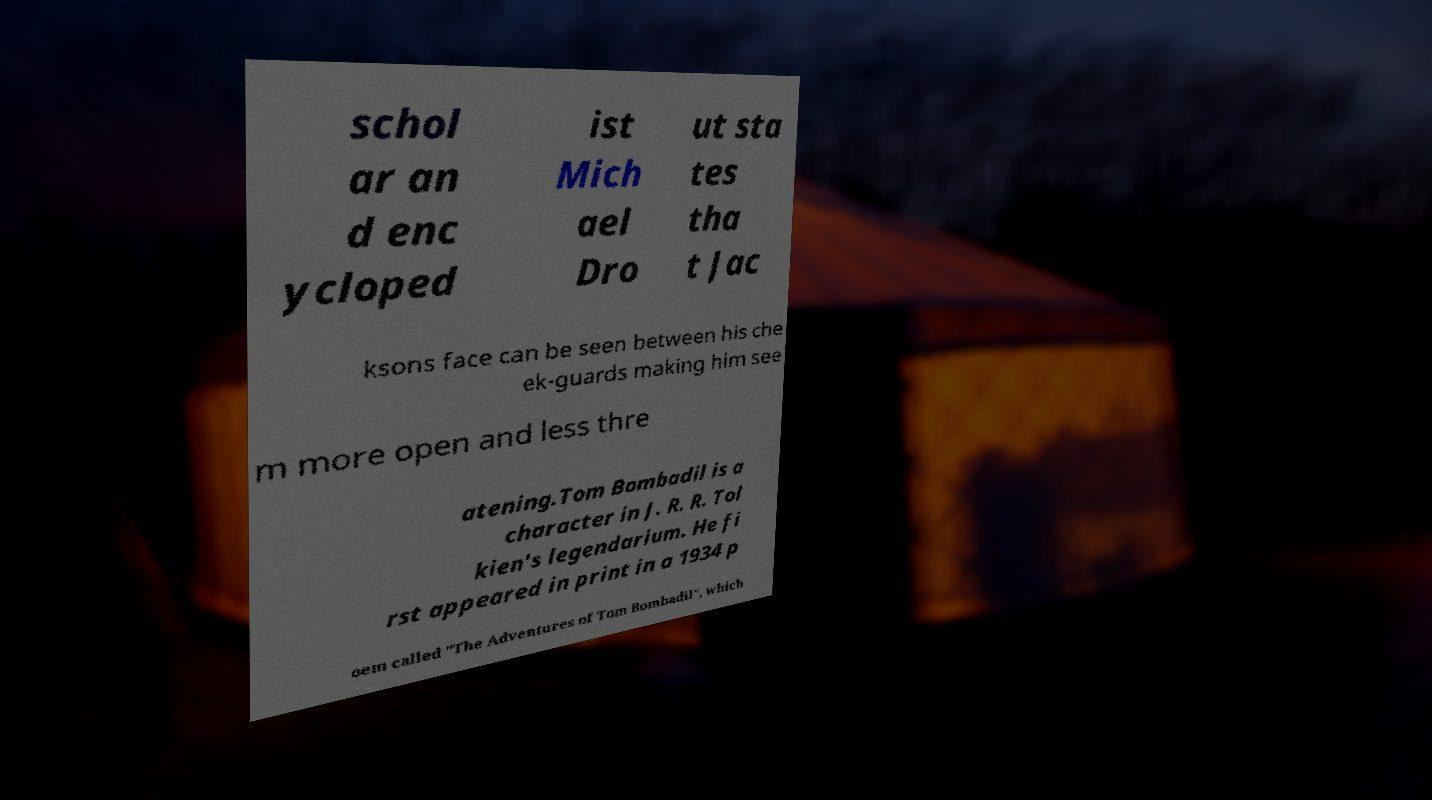For documentation purposes, I need the text within this image transcribed. Could you provide that? schol ar an d enc ycloped ist Mich ael Dro ut sta tes tha t Jac ksons face can be seen between his che ek-guards making him see m more open and less thre atening.Tom Bombadil is a character in J. R. R. Tol kien's legendarium. He fi rst appeared in print in a 1934 p oem called "The Adventures of Tom Bombadil", which 